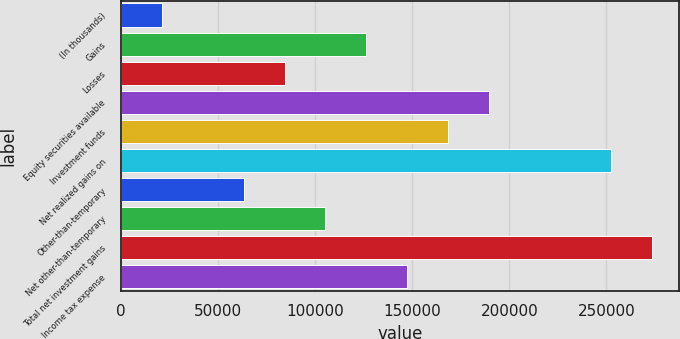Convert chart. <chart><loc_0><loc_0><loc_500><loc_500><bar_chart><fcel>(In thousands)<fcel>Gains<fcel>Losses<fcel>Equity securities available<fcel>Investment funds<fcel>Net realized gains on<fcel>Other-than-temporary<fcel>Net other-than-temporary<fcel>Total net investment gains<fcel>Income tax expense<nl><fcel>21115.8<fcel>126310<fcel>84232.2<fcel>189426<fcel>168387<fcel>252543<fcel>63193.4<fcel>105271<fcel>273581<fcel>147349<nl></chart> 